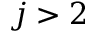Convert formula to latex. <formula><loc_0><loc_0><loc_500><loc_500>j > 2</formula> 